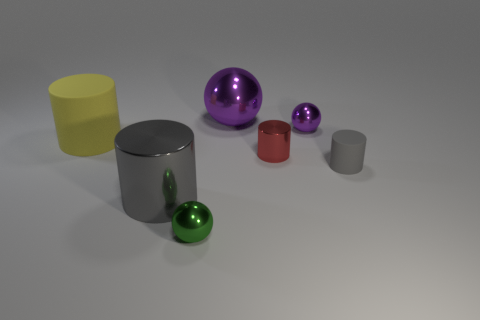Add 1 green shiny objects. How many objects exist? 8 Subtract all balls. How many objects are left? 4 Subtract all tiny rubber cylinders. Subtract all tiny gray cylinders. How many objects are left? 5 Add 4 gray metal things. How many gray metal things are left? 5 Add 3 large rubber cylinders. How many large rubber cylinders exist? 4 Subtract 0 blue cubes. How many objects are left? 7 